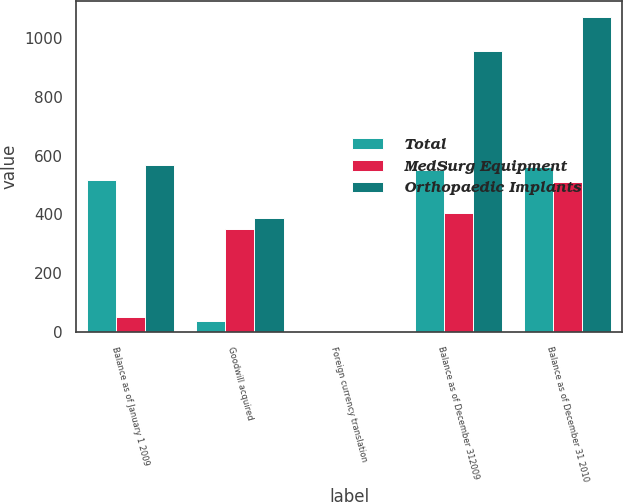<chart> <loc_0><loc_0><loc_500><loc_500><stacked_bar_chart><ecel><fcel>Balance as of January 1 2009<fcel>Goodwill acquired<fcel>Foreign currency translation<fcel>Balance as of December 312009<fcel>Balance as of December 31 2010<nl><fcel>Total<fcel>517.6<fcel>36.3<fcel>1.6<fcel>552.3<fcel>561.6<nl><fcel>MedSurg Equipment<fcel>49.9<fcel>351.2<fcel>3.4<fcel>404.5<fcel>510.7<nl><fcel>Orthopaedic Implants<fcel>567.5<fcel>387.5<fcel>1.8<fcel>956.8<fcel>1072.3<nl></chart> 